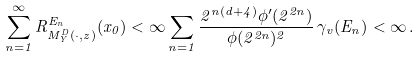Convert formula to latex. <formula><loc_0><loc_0><loc_500><loc_500>\sum _ { n = 1 } ^ { \infty } R ^ { E _ { n } } _ { M ^ { D } _ { Y } ( \cdot , z ) } ( x _ { 0 } ) < \infty \sum _ { n = 1 } \frac { 2 ^ { n ( d + 4 ) } \phi ^ { \prime } ( 2 ^ { 2 n } ) } { \phi ( 2 ^ { 2 n } ) ^ { 2 } } \, \gamma _ { v } ( E _ { n } ) < \infty \, .</formula> 